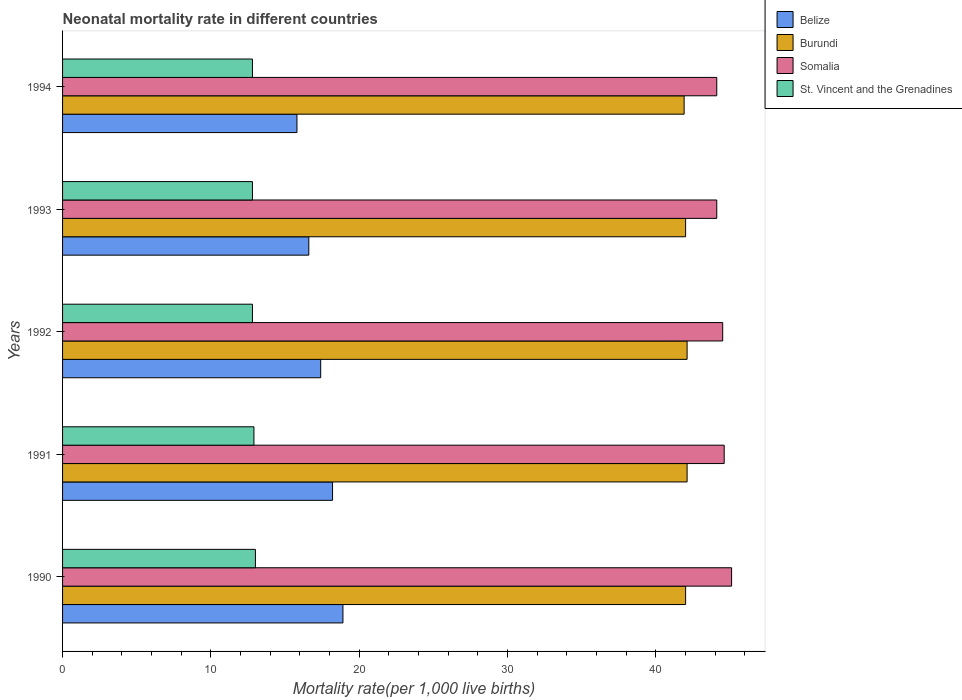Are the number of bars per tick equal to the number of legend labels?
Your answer should be compact. Yes. Are the number of bars on each tick of the Y-axis equal?
Offer a very short reply. Yes. What is the label of the 3rd group of bars from the top?
Ensure brevity in your answer.  1992. In how many cases, is the number of bars for a given year not equal to the number of legend labels?
Offer a very short reply. 0. What is the neonatal mortality rate in St. Vincent and the Grenadines in 1990?
Your answer should be compact. 13. Across all years, what is the maximum neonatal mortality rate in Belize?
Make the answer very short. 18.9. Across all years, what is the minimum neonatal mortality rate in Belize?
Give a very brief answer. 15.8. In which year was the neonatal mortality rate in Burundi maximum?
Make the answer very short. 1991. In which year was the neonatal mortality rate in Belize minimum?
Provide a succinct answer. 1994. What is the total neonatal mortality rate in Somalia in the graph?
Your answer should be compact. 222.4. What is the difference between the neonatal mortality rate in Burundi in 1990 and that in 1991?
Your answer should be compact. -0.1. What is the difference between the neonatal mortality rate in St. Vincent and the Grenadines in 1994 and the neonatal mortality rate in Somalia in 1991?
Your answer should be very brief. -31.8. What is the average neonatal mortality rate in Somalia per year?
Give a very brief answer. 44.48. In the year 1990, what is the difference between the neonatal mortality rate in Belize and neonatal mortality rate in St. Vincent and the Grenadines?
Provide a succinct answer. 5.9. What is the ratio of the neonatal mortality rate in St. Vincent and the Grenadines in 1990 to that in 1993?
Offer a terse response. 1.02. Is the neonatal mortality rate in Somalia in 1990 less than that in 1994?
Offer a terse response. No. What is the difference between the highest and the second highest neonatal mortality rate in Somalia?
Make the answer very short. 0.5. What is the difference between the highest and the lowest neonatal mortality rate in St. Vincent and the Grenadines?
Provide a short and direct response. 0.2. Is it the case that in every year, the sum of the neonatal mortality rate in Belize and neonatal mortality rate in St. Vincent and the Grenadines is greater than the sum of neonatal mortality rate in Burundi and neonatal mortality rate in Somalia?
Make the answer very short. Yes. What does the 2nd bar from the top in 1990 represents?
Keep it short and to the point. Somalia. What does the 1st bar from the bottom in 1991 represents?
Your answer should be compact. Belize. How many bars are there?
Your response must be concise. 20. Are all the bars in the graph horizontal?
Ensure brevity in your answer.  Yes. What is the difference between two consecutive major ticks on the X-axis?
Give a very brief answer. 10. Does the graph contain grids?
Your response must be concise. No. What is the title of the graph?
Make the answer very short. Neonatal mortality rate in different countries. Does "Chad" appear as one of the legend labels in the graph?
Your response must be concise. No. What is the label or title of the X-axis?
Offer a very short reply. Mortality rate(per 1,0 live births). What is the label or title of the Y-axis?
Your answer should be very brief. Years. What is the Mortality rate(per 1,000 live births) in Belize in 1990?
Your response must be concise. 18.9. What is the Mortality rate(per 1,000 live births) of Somalia in 1990?
Your answer should be compact. 45.1. What is the Mortality rate(per 1,000 live births) in Burundi in 1991?
Provide a short and direct response. 42.1. What is the Mortality rate(per 1,000 live births) in Somalia in 1991?
Make the answer very short. 44.6. What is the Mortality rate(per 1,000 live births) in Belize in 1992?
Offer a very short reply. 17.4. What is the Mortality rate(per 1,000 live births) of Burundi in 1992?
Provide a short and direct response. 42.1. What is the Mortality rate(per 1,000 live births) in Somalia in 1992?
Ensure brevity in your answer.  44.5. What is the Mortality rate(per 1,000 live births) of Somalia in 1993?
Keep it short and to the point. 44.1. What is the Mortality rate(per 1,000 live births) in Burundi in 1994?
Make the answer very short. 41.9. What is the Mortality rate(per 1,000 live births) of Somalia in 1994?
Your answer should be very brief. 44.1. Across all years, what is the maximum Mortality rate(per 1,000 live births) of Belize?
Your answer should be compact. 18.9. Across all years, what is the maximum Mortality rate(per 1,000 live births) in Burundi?
Your answer should be compact. 42.1. Across all years, what is the maximum Mortality rate(per 1,000 live births) of Somalia?
Offer a very short reply. 45.1. Across all years, what is the minimum Mortality rate(per 1,000 live births) in Belize?
Provide a succinct answer. 15.8. Across all years, what is the minimum Mortality rate(per 1,000 live births) in Burundi?
Provide a short and direct response. 41.9. Across all years, what is the minimum Mortality rate(per 1,000 live births) in Somalia?
Offer a very short reply. 44.1. What is the total Mortality rate(per 1,000 live births) of Belize in the graph?
Your answer should be very brief. 86.9. What is the total Mortality rate(per 1,000 live births) in Burundi in the graph?
Provide a short and direct response. 210.1. What is the total Mortality rate(per 1,000 live births) in Somalia in the graph?
Your answer should be very brief. 222.4. What is the total Mortality rate(per 1,000 live births) in St. Vincent and the Grenadines in the graph?
Offer a very short reply. 64.3. What is the difference between the Mortality rate(per 1,000 live births) in Somalia in 1990 and that in 1991?
Your response must be concise. 0.5. What is the difference between the Mortality rate(per 1,000 live births) of St. Vincent and the Grenadines in 1990 and that in 1991?
Offer a terse response. 0.1. What is the difference between the Mortality rate(per 1,000 live births) of Somalia in 1990 and that in 1992?
Keep it short and to the point. 0.6. What is the difference between the Mortality rate(per 1,000 live births) of Belize in 1990 and that in 1993?
Provide a succinct answer. 2.3. What is the difference between the Mortality rate(per 1,000 live births) in Somalia in 1990 and that in 1993?
Offer a terse response. 1. What is the difference between the Mortality rate(per 1,000 live births) in Burundi in 1990 and that in 1994?
Provide a short and direct response. 0.1. What is the difference between the Mortality rate(per 1,000 live births) of Belize in 1991 and that in 1992?
Provide a succinct answer. 0.8. What is the difference between the Mortality rate(per 1,000 live births) in Somalia in 1991 and that in 1992?
Your answer should be compact. 0.1. What is the difference between the Mortality rate(per 1,000 live births) in St. Vincent and the Grenadines in 1991 and that in 1992?
Offer a very short reply. 0.1. What is the difference between the Mortality rate(per 1,000 live births) of Belize in 1991 and that in 1993?
Your answer should be very brief. 1.6. What is the difference between the Mortality rate(per 1,000 live births) in St. Vincent and the Grenadines in 1991 and that in 1993?
Ensure brevity in your answer.  0.1. What is the difference between the Mortality rate(per 1,000 live births) of Belize in 1991 and that in 1994?
Your answer should be very brief. 2.4. What is the difference between the Mortality rate(per 1,000 live births) of Belize in 1992 and that in 1993?
Provide a short and direct response. 0.8. What is the difference between the Mortality rate(per 1,000 live births) of Somalia in 1992 and that in 1993?
Your answer should be compact. 0.4. What is the difference between the Mortality rate(per 1,000 live births) in St. Vincent and the Grenadines in 1992 and that in 1993?
Give a very brief answer. 0. What is the difference between the Mortality rate(per 1,000 live births) of Belize in 1992 and that in 1994?
Give a very brief answer. 1.6. What is the difference between the Mortality rate(per 1,000 live births) of Burundi in 1992 and that in 1994?
Your response must be concise. 0.2. What is the difference between the Mortality rate(per 1,000 live births) in Somalia in 1992 and that in 1994?
Your response must be concise. 0.4. What is the difference between the Mortality rate(per 1,000 live births) in Belize in 1990 and the Mortality rate(per 1,000 live births) in Burundi in 1991?
Your answer should be compact. -23.2. What is the difference between the Mortality rate(per 1,000 live births) of Belize in 1990 and the Mortality rate(per 1,000 live births) of Somalia in 1991?
Offer a terse response. -25.7. What is the difference between the Mortality rate(per 1,000 live births) in Belize in 1990 and the Mortality rate(per 1,000 live births) in St. Vincent and the Grenadines in 1991?
Make the answer very short. 6. What is the difference between the Mortality rate(per 1,000 live births) of Burundi in 1990 and the Mortality rate(per 1,000 live births) of Somalia in 1991?
Your response must be concise. -2.6. What is the difference between the Mortality rate(per 1,000 live births) in Burundi in 1990 and the Mortality rate(per 1,000 live births) in St. Vincent and the Grenadines in 1991?
Keep it short and to the point. 29.1. What is the difference between the Mortality rate(per 1,000 live births) in Somalia in 1990 and the Mortality rate(per 1,000 live births) in St. Vincent and the Grenadines in 1991?
Provide a short and direct response. 32.2. What is the difference between the Mortality rate(per 1,000 live births) of Belize in 1990 and the Mortality rate(per 1,000 live births) of Burundi in 1992?
Offer a terse response. -23.2. What is the difference between the Mortality rate(per 1,000 live births) in Belize in 1990 and the Mortality rate(per 1,000 live births) in Somalia in 1992?
Your answer should be compact. -25.6. What is the difference between the Mortality rate(per 1,000 live births) of Burundi in 1990 and the Mortality rate(per 1,000 live births) of St. Vincent and the Grenadines in 1992?
Provide a short and direct response. 29.2. What is the difference between the Mortality rate(per 1,000 live births) of Somalia in 1990 and the Mortality rate(per 1,000 live births) of St. Vincent and the Grenadines in 1992?
Ensure brevity in your answer.  32.3. What is the difference between the Mortality rate(per 1,000 live births) in Belize in 1990 and the Mortality rate(per 1,000 live births) in Burundi in 1993?
Your answer should be compact. -23.1. What is the difference between the Mortality rate(per 1,000 live births) in Belize in 1990 and the Mortality rate(per 1,000 live births) in Somalia in 1993?
Provide a succinct answer. -25.2. What is the difference between the Mortality rate(per 1,000 live births) in Belize in 1990 and the Mortality rate(per 1,000 live births) in St. Vincent and the Grenadines in 1993?
Provide a succinct answer. 6.1. What is the difference between the Mortality rate(per 1,000 live births) in Burundi in 1990 and the Mortality rate(per 1,000 live births) in Somalia in 1993?
Provide a short and direct response. -2.1. What is the difference between the Mortality rate(per 1,000 live births) of Burundi in 1990 and the Mortality rate(per 1,000 live births) of St. Vincent and the Grenadines in 1993?
Give a very brief answer. 29.2. What is the difference between the Mortality rate(per 1,000 live births) in Somalia in 1990 and the Mortality rate(per 1,000 live births) in St. Vincent and the Grenadines in 1993?
Keep it short and to the point. 32.3. What is the difference between the Mortality rate(per 1,000 live births) in Belize in 1990 and the Mortality rate(per 1,000 live births) in Somalia in 1994?
Ensure brevity in your answer.  -25.2. What is the difference between the Mortality rate(per 1,000 live births) of Burundi in 1990 and the Mortality rate(per 1,000 live births) of Somalia in 1994?
Your response must be concise. -2.1. What is the difference between the Mortality rate(per 1,000 live births) in Burundi in 1990 and the Mortality rate(per 1,000 live births) in St. Vincent and the Grenadines in 1994?
Your answer should be very brief. 29.2. What is the difference between the Mortality rate(per 1,000 live births) in Somalia in 1990 and the Mortality rate(per 1,000 live births) in St. Vincent and the Grenadines in 1994?
Make the answer very short. 32.3. What is the difference between the Mortality rate(per 1,000 live births) of Belize in 1991 and the Mortality rate(per 1,000 live births) of Burundi in 1992?
Your answer should be very brief. -23.9. What is the difference between the Mortality rate(per 1,000 live births) in Belize in 1991 and the Mortality rate(per 1,000 live births) in Somalia in 1992?
Make the answer very short. -26.3. What is the difference between the Mortality rate(per 1,000 live births) in Burundi in 1991 and the Mortality rate(per 1,000 live births) in St. Vincent and the Grenadines in 1992?
Your answer should be compact. 29.3. What is the difference between the Mortality rate(per 1,000 live births) of Somalia in 1991 and the Mortality rate(per 1,000 live births) of St. Vincent and the Grenadines in 1992?
Provide a succinct answer. 31.8. What is the difference between the Mortality rate(per 1,000 live births) in Belize in 1991 and the Mortality rate(per 1,000 live births) in Burundi in 1993?
Give a very brief answer. -23.8. What is the difference between the Mortality rate(per 1,000 live births) of Belize in 1991 and the Mortality rate(per 1,000 live births) of Somalia in 1993?
Offer a very short reply. -25.9. What is the difference between the Mortality rate(per 1,000 live births) in Belize in 1991 and the Mortality rate(per 1,000 live births) in St. Vincent and the Grenadines in 1993?
Provide a short and direct response. 5.4. What is the difference between the Mortality rate(per 1,000 live births) of Burundi in 1991 and the Mortality rate(per 1,000 live births) of St. Vincent and the Grenadines in 1993?
Offer a terse response. 29.3. What is the difference between the Mortality rate(per 1,000 live births) in Somalia in 1991 and the Mortality rate(per 1,000 live births) in St. Vincent and the Grenadines in 1993?
Provide a succinct answer. 31.8. What is the difference between the Mortality rate(per 1,000 live births) of Belize in 1991 and the Mortality rate(per 1,000 live births) of Burundi in 1994?
Offer a very short reply. -23.7. What is the difference between the Mortality rate(per 1,000 live births) of Belize in 1991 and the Mortality rate(per 1,000 live births) of Somalia in 1994?
Provide a short and direct response. -25.9. What is the difference between the Mortality rate(per 1,000 live births) of Belize in 1991 and the Mortality rate(per 1,000 live births) of St. Vincent and the Grenadines in 1994?
Provide a short and direct response. 5.4. What is the difference between the Mortality rate(per 1,000 live births) in Burundi in 1991 and the Mortality rate(per 1,000 live births) in St. Vincent and the Grenadines in 1994?
Your answer should be very brief. 29.3. What is the difference between the Mortality rate(per 1,000 live births) of Somalia in 1991 and the Mortality rate(per 1,000 live births) of St. Vincent and the Grenadines in 1994?
Give a very brief answer. 31.8. What is the difference between the Mortality rate(per 1,000 live births) of Belize in 1992 and the Mortality rate(per 1,000 live births) of Burundi in 1993?
Give a very brief answer. -24.6. What is the difference between the Mortality rate(per 1,000 live births) in Belize in 1992 and the Mortality rate(per 1,000 live births) in Somalia in 1993?
Make the answer very short. -26.7. What is the difference between the Mortality rate(per 1,000 live births) of Burundi in 1992 and the Mortality rate(per 1,000 live births) of St. Vincent and the Grenadines in 1993?
Ensure brevity in your answer.  29.3. What is the difference between the Mortality rate(per 1,000 live births) in Somalia in 1992 and the Mortality rate(per 1,000 live births) in St. Vincent and the Grenadines in 1993?
Keep it short and to the point. 31.7. What is the difference between the Mortality rate(per 1,000 live births) of Belize in 1992 and the Mortality rate(per 1,000 live births) of Burundi in 1994?
Ensure brevity in your answer.  -24.5. What is the difference between the Mortality rate(per 1,000 live births) in Belize in 1992 and the Mortality rate(per 1,000 live births) in Somalia in 1994?
Your answer should be very brief. -26.7. What is the difference between the Mortality rate(per 1,000 live births) of Burundi in 1992 and the Mortality rate(per 1,000 live births) of Somalia in 1994?
Offer a very short reply. -2. What is the difference between the Mortality rate(per 1,000 live births) of Burundi in 1992 and the Mortality rate(per 1,000 live births) of St. Vincent and the Grenadines in 1994?
Your response must be concise. 29.3. What is the difference between the Mortality rate(per 1,000 live births) in Somalia in 1992 and the Mortality rate(per 1,000 live births) in St. Vincent and the Grenadines in 1994?
Ensure brevity in your answer.  31.7. What is the difference between the Mortality rate(per 1,000 live births) of Belize in 1993 and the Mortality rate(per 1,000 live births) of Burundi in 1994?
Your response must be concise. -25.3. What is the difference between the Mortality rate(per 1,000 live births) of Belize in 1993 and the Mortality rate(per 1,000 live births) of Somalia in 1994?
Your answer should be very brief. -27.5. What is the difference between the Mortality rate(per 1,000 live births) of Burundi in 1993 and the Mortality rate(per 1,000 live births) of St. Vincent and the Grenadines in 1994?
Your answer should be compact. 29.2. What is the difference between the Mortality rate(per 1,000 live births) in Somalia in 1993 and the Mortality rate(per 1,000 live births) in St. Vincent and the Grenadines in 1994?
Make the answer very short. 31.3. What is the average Mortality rate(per 1,000 live births) in Belize per year?
Offer a terse response. 17.38. What is the average Mortality rate(per 1,000 live births) in Burundi per year?
Offer a very short reply. 42.02. What is the average Mortality rate(per 1,000 live births) in Somalia per year?
Give a very brief answer. 44.48. What is the average Mortality rate(per 1,000 live births) of St. Vincent and the Grenadines per year?
Make the answer very short. 12.86. In the year 1990, what is the difference between the Mortality rate(per 1,000 live births) of Belize and Mortality rate(per 1,000 live births) of Burundi?
Give a very brief answer. -23.1. In the year 1990, what is the difference between the Mortality rate(per 1,000 live births) of Belize and Mortality rate(per 1,000 live births) of Somalia?
Your answer should be compact. -26.2. In the year 1990, what is the difference between the Mortality rate(per 1,000 live births) of Somalia and Mortality rate(per 1,000 live births) of St. Vincent and the Grenadines?
Offer a terse response. 32.1. In the year 1991, what is the difference between the Mortality rate(per 1,000 live births) in Belize and Mortality rate(per 1,000 live births) in Burundi?
Give a very brief answer. -23.9. In the year 1991, what is the difference between the Mortality rate(per 1,000 live births) of Belize and Mortality rate(per 1,000 live births) of Somalia?
Provide a short and direct response. -26.4. In the year 1991, what is the difference between the Mortality rate(per 1,000 live births) of Burundi and Mortality rate(per 1,000 live births) of Somalia?
Your answer should be very brief. -2.5. In the year 1991, what is the difference between the Mortality rate(per 1,000 live births) in Burundi and Mortality rate(per 1,000 live births) in St. Vincent and the Grenadines?
Give a very brief answer. 29.2. In the year 1991, what is the difference between the Mortality rate(per 1,000 live births) in Somalia and Mortality rate(per 1,000 live births) in St. Vincent and the Grenadines?
Offer a very short reply. 31.7. In the year 1992, what is the difference between the Mortality rate(per 1,000 live births) of Belize and Mortality rate(per 1,000 live births) of Burundi?
Keep it short and to the point. -24.7. In the year 1992, what is the difference between the Mortality rate(per 1,000 live births) of Belize and Mortality rate(per 1,000 live births) of Somalia?
Your answer should be very brief. -27.1. In the year 1992, what is the difference between the Mortality rate(per 1,000 live births) in Belize and Mortality rate(per 1,000 live births) in St. Vincent and the Grenadines?
Provide a succinct answer. 4.6. In the year 1992, what is the difference between the Mortality rate(per 1,000 live births) of Burundi and Mortality rate(per 1,000 live births) of Somalia?
Offer a very short reply. -2.4. In the year 1992, what is the difference between the Mortality rate(per 1,000 live births) in Burundi and Mortality rate(per 1,000 live births) in St. Vincent and the Grenadines?
Your response must be concise. 29.3. In the year 1992, what is the difference between the Mortality rate(per 1,000 live births) of Somalia and Mortality rate(per 1,000 live births) of St. Vincent and the Grenadines?
Provide a succinct answer. 31.7. In the year 1993, what is the difference between the Mortality rate(per 1,000 live births) of Belize and Mortality rate(per 1,000 live births) of Burundi?
Offer a terse response. -25.4. In the year 1993, what is the difference between the Mortality rate(per 1,000 live births) of Belize and Mortality rate(per 1,000 live births) of Somalia?
Your answer should be compact. -27.5. In the year 1993, what is the difference between the Mortality rate(per 1,000 live births) in Belize and Mortality rate(per 1,000 live births) in St. Vincent and the Grenadines?
Ensure brevity in your answer.  3.8. In the year 1993, what is the difference between the Mortality rate(per 1,000 live births) in Burundi and Mortality rate(per 1,000 live births) in St. Vincent and the Grenadines?
Make the answer very short. 29.2. In the year 1993, what is the difference between the Mortality rate(per 1,000 live births) of Somalia and Mortality rate(per 1,000 live births) of St. Vincent and the Grenadines?
Your answer should be compact. 31.3. In the year 1994, what is the difference between the Mortality rate(per 1,000 live births) of Belize and Mortality rate(per 1,000 live births) of Burundi?
Your answer should be very brief. -26.1. In the year 1994, what is the difference between the Mortality rate(per 1,000 live births) of Belize and Mortality rate(per 1,000 live births) of Somalia?
Provide a succinct answer. -28.3. In the year 1994, what is the difference between the Mortality rate(per 1,000 live births) in Belize and Mortality rate(per 1,000 live births) in St. Vincent and the Grenadines?
Offer a terse response. 3. In the year 1994, what is the difference between the Mortality rate(per 1,000 live births) in Burundi and Mortality rate(per 1,000 live births) in Somalia?
Your response must be concise. -2.2. In the year 1994, what is the difference between the Mortality rate(per 1,000 live births) of Burundi and Mortality rate(per 1,000 live births) of St. Vincent and the Grenadines?
Your answer should be compact. 29.1. In the year 1994, what is the difference between the Mortality rate(per 1,000 live births) of Somalia and Mortality rate(per 1,000 live births) of St. Vincent and the Grenadines?
Your response must be concise. 31.3. What is the ratio of the Mortality rate(per 1,000 live births) of Belize in 1990 to that in 1991?
Provide a succinct answer. 1.04. What is the ratio of the Mortality rate(per 1,000 live births) in Somalia in 1990 to that in 1991?
Give a very brief answer. 1.01. What is the ratio of the Mortality rate(per 1,000 live births) in Belize in 1990 to that in 1992?
Ensure brevity in your answer.  1.09. What is the ratio of the Mortality rate(per 1,000 live births) of Burundi in 1990 to that in 1992?
Ensure brevity in your answer.  1. What is the ratio of the Mortality rate(per 1,000 live births) of Somalia in 1990 to that in 1992?
Your response must be concise. 1.01. What is the ratio of the Mortality rate(per 1,000 live births) in St. Vincent and the Grenadines in 1990 to that in 1992?
Your response must be concise. 1.02. What is the ratio of the Mortality rate(per 1,000 live births) in Belize in 1990 to that in 1993?
Offer a very short reply. 1.14. What is the ratio of the Mortality rate(per 1,000 live births) in Burundi in 1990 to that in 1993?
Your answer should be very brief. 1. What is the ratio of the Mortality rate(per 1,000 live births) in Somalia in 1990 to that in 1993?
Offer a very short reply. 1.02. What is the ratio of the Mortality rate(per 1,000 live births) of St. Vincent and the Grenadines in 1990 to that in 1993?
Make the answer very short. 1.02. What is the ratio of the Mortality rate(per 1,000 live births) in Belize in 1990 to that in 1994?
Make the answer very short. 1.2. What is the ratio of the Mortality rate(per 1,000 live births) of Somalia in 1990 to that in 1994?
Offer a very short reply. 1.02. What is the ratio of the Mortality rate(per 1,000 live births) in St. Vincent and the Grenadines in 1990 to that in 1994?
Give a very brief answer. 1.02. What is the ratio of the Mortality rate(per 1,000 live births) in Belize in 1991 to that in 1992?
Ensure brevity in your answer.  1.05. What is the ratio of the Mortality rate(per 1,000 live births) in Burundi in 1991 to that in 1992?
Offer a terse response. 1. What is the ratio of the Mortality rate(per 1,000 live births) in Belize in 1991 to that in 1993?
Keep it short and to the point. 1.1. What is the ratio of the Mortality rate(per 1,000 live births) in Burundi in 1991 to that in 1993?
Offer a terse response. 1. What is the ratio of the Mortality rate(per 1,000 live births) in Somalia in 1991 to that in 1993?
Keep it short and to the point. 1.01. What is the ratio of the Mortality rate(per 1,000 live births) in St. Vincent and the Grenadines in 1991 to that in 1993?
Offer a terse response. 1.01. What is the ratio of the Mortality rate(per 1,000 live births) of Belize in 1991 to that in 1994?
Your answer should be compact. 1.15. What is the ratio of the Mortality rate(per 1,000 live births) in Burundi in 1991 to that in 1994?
Ensure brevity in your answer.  1. What is the ratio of the Mortality rate(per 1,000 live births) in Somalia in 1991 to that in 1994?
Provide a succinct answer. 1.01. What is the ratio of the Mortality rate(per 1,000 live births) of Belize in 1992 to that in 1993?
Offer a very short reply. 1.05. What is the ratio of the Mortality rate(per 1,000 live births) of Burundi in 1992 to that in 1993?
Provide a succinct answer. 1. What is the ratio of the Mortality rate(per 1,000 live births) in Somalia in 1992 to that in 1993?
Give a very brief answer. 1.01. What is the ratio of the Mortality rate(per 1,000 live births) of Belize in 1992 to that in 1994?
Keep it short and to the point. 1.1. What is the ratio of the Mortality rate(per 1,000 live births) in Burundi in 1992 to that in 1994?
Ensure brevity in your answer.  1. What is the ratio of the Mortality rate(per 1,000 live births) of Somalia in 1992 to that in 1994?
Your answer should be very brief. 1.01. What is the ratio of the Mortality rate(per 1,000 live births) of St. Vincent and the Grenadines in 1992 to that in 1994?
Provide a succinct answer. 1. What is the ratio of the Mortality rate(per 1,000 live births) in Belize in 1993 to that in 1994?
Keep it short and to the point. 1.05. What is the ratio of the Mortality rate(per 1,000 live births) in St. Vincent and the Grenadines in 1993 to that in 1994?
Offer a very short reply. 1. What is the difference between the highest and the second highest Mortality rate(per 1,000 live births) in Belize?
Keep it short and to the point. 0.7. What is the difference between the highest and the second highest Mortality rate(per 1,000 live births) in Burundi?
Offer a terse response. 0. What is the difference between the highest and the second highest Mortality rate(per 1,000 live births) of Somalia?
Offer a terse response. 0.5. What is the difference between the highest and the second highest Mortality rate(per 1,000 live births) of St. Vincent and the Grenadines?
Provide a short and direct response. 0.1. What is the difference between the highest and the lowest Mortality rate(per 1,000 live births) of Belize?
Keep it short and to the point. 3.1. What is the difference between the highest and the lowest Mortality rate(per 1,000 live births) of St. Vincent and the Grenadines?
Keep it short and to the point. 0.2. 